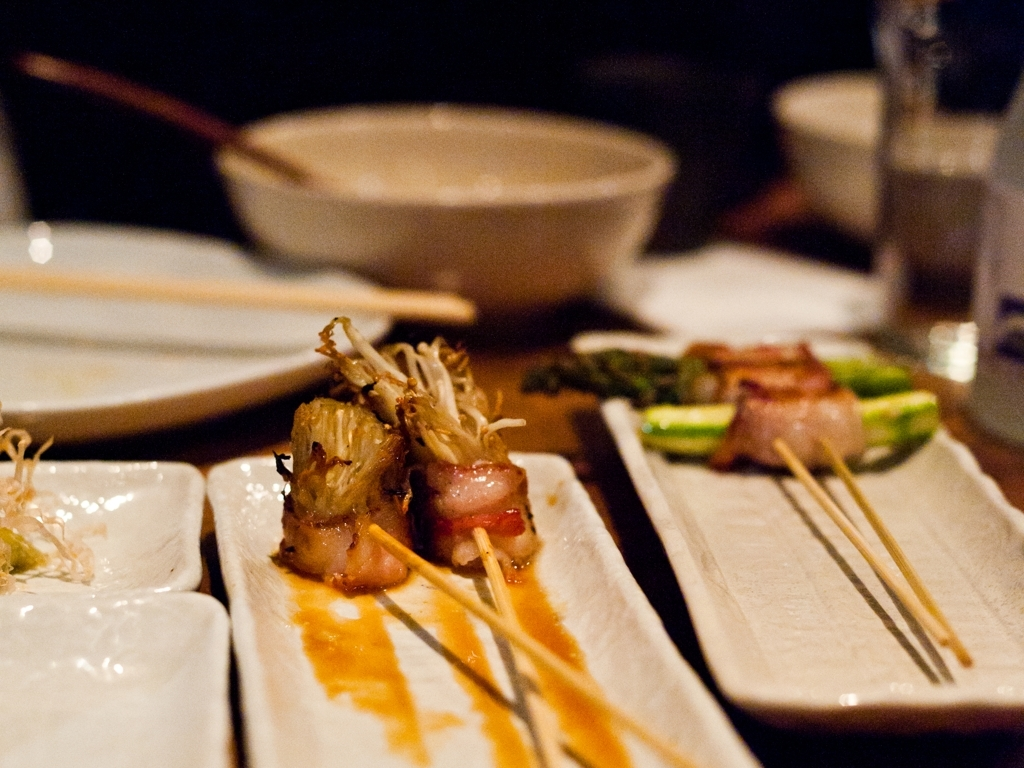What is the quality of the color? The color palette in the image is warm and inviting, with a rich golden hue that suggests the food is well-cooked and flavorsome. The ambient lighting accentuates the vibrancy of the colors, giving the dishes an appetizing appearance. 